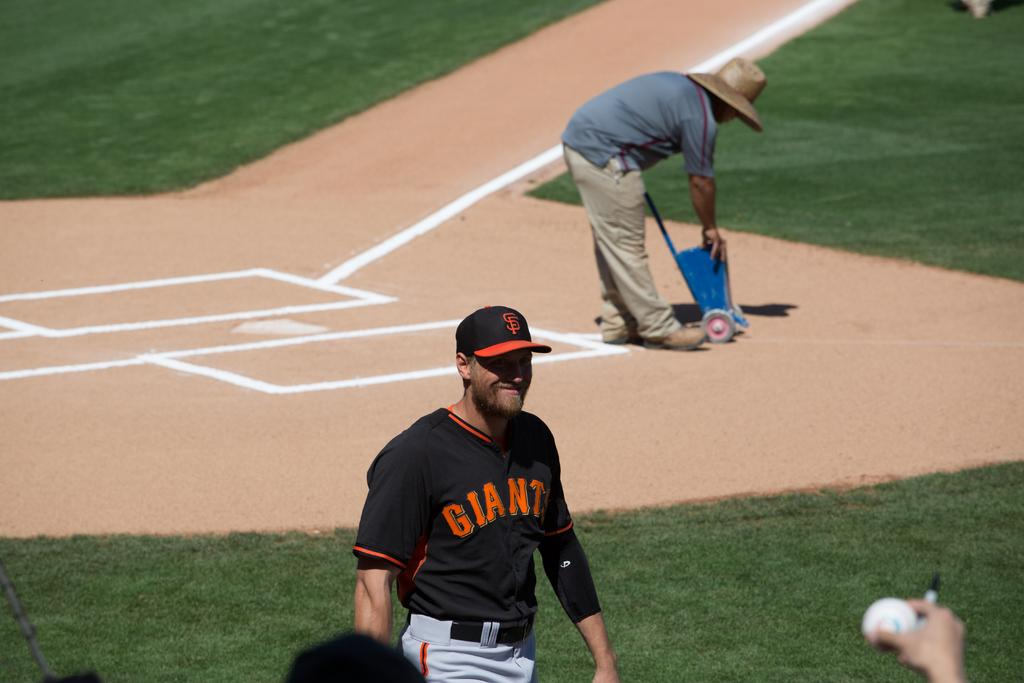Provide a one-sentence caption for the provided image. A player for the Giants baseball team smiles as he walks across the field. 